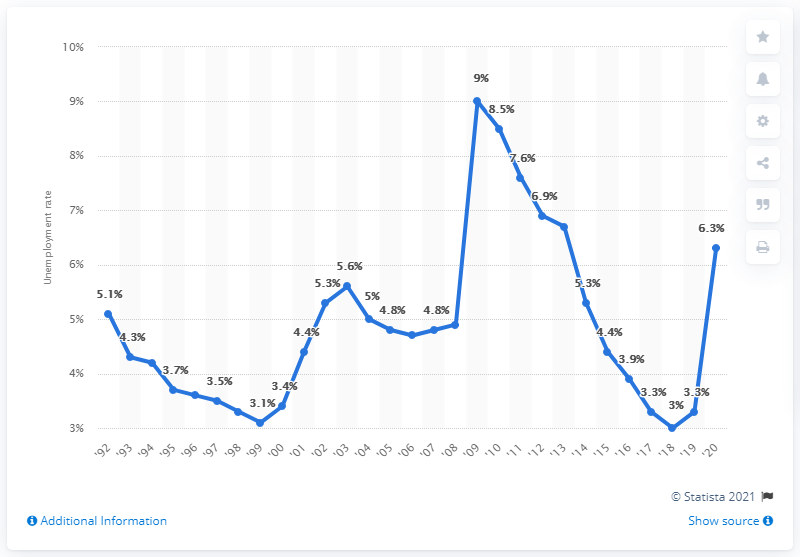Identify some key points in this picture. In 2020, the unemployment rate in Wisconsin was 6.3%. 